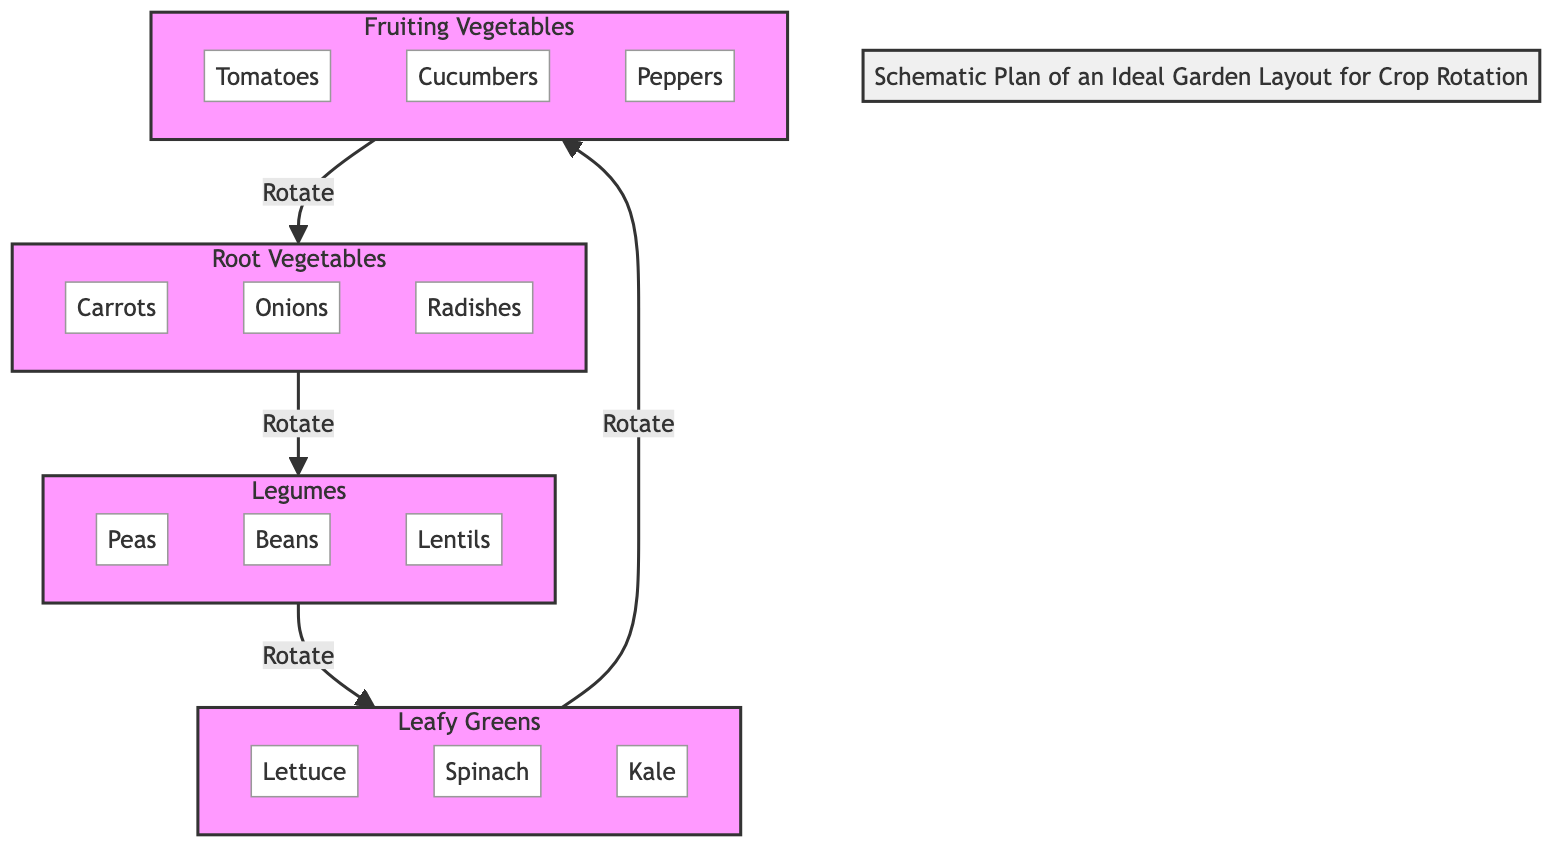What type of crops are included in the Root Vegetables section? The Root Vegetables section contains three specific crops: Carrots, Onions, and Radishes. These are clearly listed under the RV subgraph in the diagram.
Answer: Carrots, Onions, Radishes How many types of crops are listed under Fruiting Vegetables? In the Fruiting Vegetables section, there are three distinct crops: Tomatoes, Cucumbers, and Peppers. This is evident from the FV subgraph.
Answer: 3 Which section follows Leafy Greens in the crop rotation sequence? The diagram shows that Leafy Greens (LF) lead to Fruiting Vegetables (FV) in the crop rotation, connecting them in the order outlined in the relationships between the subgraphs.
Answer: Fruiting Vegetables What is the total number of crops presented in the diagram? By counting the individual crops listed in all four sections (Root Vegetables, Legumes, Leafy Greens, and Fruiting Vegetables), we find that there are a total of 12 crops (3 from RV, 3 from LG, 3 from LF, and 3 from FV).
Answer: 12 What relationship exists between Legumes and Leafy Greens in the diagram? The diagram indicates a rotational relationship where Legumes (LG) are directly connected to Leafy Greens (LF), meaning Legumes should follow Legumes during the crop rotation process.
Answer: Rotate Which vegetable group does Spinach belong to? Spinach is listed under the Leafy Greens section (LF) in the diagram, indicating its classification as a leafy crop within that group.
Answer: Leafy Greens 